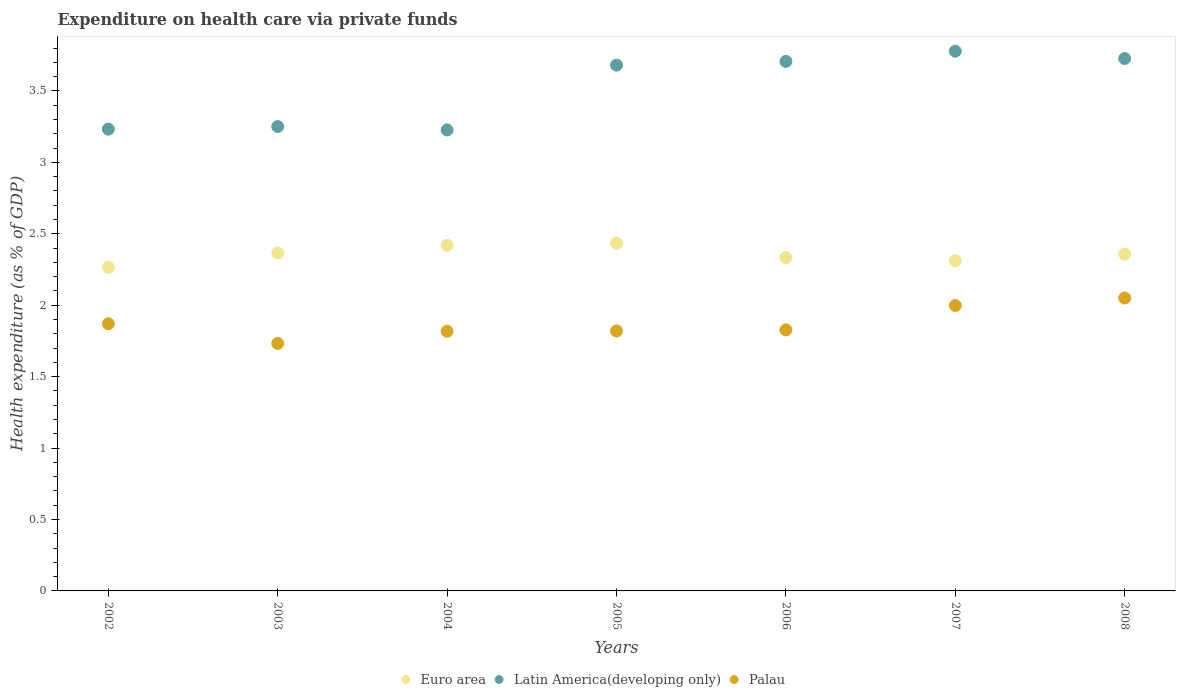Is the number of dotlines equal to the number of legend labels?
Ensure brevity in your answer.  Yes. What is the expenditure made on health care in Palau in 2003?
Ensure brevity in your answer.  1.73. Across all years, what is the maximum expenditure made on health care in Latin America(developing only)?
Your response must be concise. 3.78. Across all years, what is the minimum expenditure made on health care in Euro area?
Your response must be concise. 2.27. What is the total expenditure made on health care in Palau in the graph?
Offer a very short reply. 13.11. What is the difference between the expenditure made on health care in Palau in 2005 and that in 2008?
Keep it short and to the point. -0.23. What is the difference between the expenditure made on health care in Latin America(developing only) in 2006 and the expenditure made on health care in Euro area in 2003?
Your answer should be compact. 1.34. What is the average expenditure made on health care in Latin America(developing only) per year?
Your answer should be compact. 3.51. In the year 2007, what is the difference between the expenditure made on health care in Latin America(developing only) and expenditure made on health care in Palau?
Your answer should be very brief. 1.78. What is the ratio of the expenditure made on health care in Latin America(developing only) in 2004 to that in 2007?
Offer a very short reply. 0.85. Is the difference between the expenditure made on health care in Latin America(developing only) in 2005 and 2008 greater than the difference between the expenditure made on health care in Palau in 2005 and 2008?
Give a very brief answer. Yes. What is the difference between the highest and the second highest expenditure made on health care in Latin America(developing only)?
Provide a succinct answer. 0.05. What is the difference between the highest and the lowest expenditure made on health care in Euro area?
Give a very brief answer. 0.17. In how many years, is the expenditure made on health care in Euro area greater than the average expenditure made on health care in Euro area taken over all years?
Ensure brevity in your answer.  4. Is it the case that in every year, the sum of the expenditure made on health care in Palau and expenditure made on health care in Euro area  is greater than the expenditure made on health care in Latin America(developing only)?
Offer a very short reply. Yes. Does the expenditure made on health care in Palau monotonically increase over the years?
Give a very brief answer. No. Is the expenditure made on health care in Euro area strictly less than the expenditure made on health care in Latin America(developing only) over the years?
Offer a very short reply. Yes. What is the difference between two consecutive major ticks on the Y-axis?
Your answer should be compact. 0.5. Does the graph contain any zero values?
Keep it short and to the point. No. Where does the legend appear in the graph?
Provide a succinct answer. Bottom center. How are the legend labels stacked?
Make the answer very short. Horizontal. What is the title of the graph?
Provide a succinct answer. Expenditure on health care via private funds. What is the label or title of the Y-axis?
Make the answer very short. Health expenditure (as % of GDP). What is the Health expenditure (as % of GDP) of Euro area in 2002?
Keep it short and to the point. 2.27. What is the Health expenditure (as % of GDP) in Latin America(developing only) in 2002?
Offer a terse response. 3.23. What is the Health expenditure (as % of GDP) of Palau in 2002?
Make the answer very short. 1.87. What is the Health expenditure (as % of GDP) in Euro area in 2003?
Your answer should be very brief. 2.36. What is the Health expenditure (as % of GDP) in Latin America(developing only) in 2003?
Ensure brevity in your answer.  3.25. What is the Health expenditure (as % of GDP) in Palau in 2003?
Make the answer very short. 1.73. What is the Health expenditure (as % of GDP) in Euro area in 2004?
Provide a succinct answer. 2.42. What is the Health expenditure (as % of GDP) of Latin America(developing only) in 2004?
Offer a terse response. 3.23. What is the Health expenditure (as % of GDP) of Palau in 2004?
Make the answer very short. 1.82. What is the Health expenditure (as % of GDP) in Euro area in 2005?
Make the answer very short. 2.43. What is the Health expenditure (as % of GDP) of Latin America(developing only) in 2005?
Ensure brevity in your answer.  3.68. What is the Health expenditure (as % of GDP) in Palau in 2005?
Ensure brevity in your answer.  1.82. What is the Health expenditure (as % of GDP) of Euro area in 2006?
Give a very brief answer. 2.33. What is the Health expenditure (as % of GDP) in Latin America(developing only) in 2006?
Your answer should be compact. 3.71. What is the Health expenditure (as % of GDP) of Palau in 2006?
Your response must be concise. 1.83. What is the Health expenditure (as % of GDP) in Euro area in 2007?
Offer a very short reply. 2.31. What is the Health expenditure (as % of GDP) of Latin America(developing only) in 2007?
Offer a terse response. 3.78. What is the Health expenditure (as % of GDP) in Palau in 2007?
Provide a short and direct response. 2. What is the Health expenditure (as % of GDP) of Euro area in 2008?
Make the answer very short. 2.36. What is the Health expenditure (as % of GDP) of Latin America(developing only) in 2008?
Provide a short and direct response. 3.73. What is the Health expenditure (as % of GDP) in Palau in 2008?
Your answer should be compact. 2.05. Across all years, what is the maximum Health expenditure (as % of GDP) in Euro area?
Offer a terse response. 2.43. Across all years, what is the maximum Health expenditure (as % of GDP) in Latin America(developing only)?
Give a very brief answer. 3.78. Across all years, what is the maximum Health expenditure (as % of GDP) of Palau?
Keep it short and to the point. 2.05. Across all years, what is the minimum Health expenditure (as % of GDP) of Euro area?
Provide a short and direct response. 2.27. Across all years, what is the minimum Health expenditure (as % of GDP) of Latin America(developing only)?
Your answer should be very brief. 3.23. Across all years, what is the minimum Health expenditure (as % of GDP) in Palau?
Offer a very short reply. 1.73. What is the total Health expenditure (as % of GDP) in Euro area in the graph?
Provide a succinct answer. 16.49. What is the total Health expenditure (as % of GDP) of Latin America(developing only) in the graph?
Your answer should be compact. 24.6. What is the total Health expenditure (as % of GDP) in Palau in the graph?
Provide a short and direct response. 13.11. What is the difference between the Health expenditure (as % of GDP) in Latin America(developing only) in 2002 and that in 2003?
Your response must be concise. -0.02. What is the difference between the Health expenditure (as % of GDP) in Palau in 2002 and that in 2003?
Keep it short and to the point. 0.14. What is the difference between the Health expenditure (as % of GDP) in Euro area in 2002 and that in 2004?
Keep it short and to the point. -0.15. What is the difference between the Health expenditure (as % of GDP) in Latin America(developing only) in 2002 and that in 2004?
Your answer should be very brief. 0.01. What is the difference between the Health expenditure (as % of GDP) in Palau in 2002 and that in 2004?
Your response must be concise. 0.05. What is the difference between the Health expenditure (as % of GDP) in Euro area in 2002 and that in 2005?
Offer a terse response. -0.17. What is the difference between the Health expenditure (as % of GDP) of Latin America(developing only) in 2002 and that in 2005?
Your answer should be very brief. -0.45. What is the difference between the Health expenditure (as % of GDP) of Palau in 2002 and that in 2005?
Offer a terse response. 0.05. What is the difference between the Health expenditure (as % of GDP) of Euro area in 2002 and that in 2006?
Offer a very short reply. -0.07. What is the difference between the Health expenditure (as % of GDP) of Latin America(developing only) in 2002 and that in 2006?
Your answer should be compact. -0.47. What is the difference between the Health expenditure (as % of GDP) in Palau in 2002 and that in 2006?
Provide a succinct answer. 0.04. What is the difference between the Health expenditure (as % of GDP) of Euro area in 2002 and that in 2007?
Offer a very short reply. -0.05. What is the difference between the Health expenditure (as % of GDP) of Latin America(developing only) in 2002 and that in 2007?
Your answer should be very brief. -0.55. What is the difference between the Health expenditure (as % of GDP) in Palau in 2002 and that in 2007?
Ensure brevity in your answer.  -0.13. What is the difference between the Health expenditure (as % of GDP) of Euro area in 2002 and that in 2008?
Provide a succinct answer. -0.09. What is the difference between the Health expenditure (as % of GDP) in Latin America(developing only) in 2002 and that in 2008?
Ensure brevity in your answer.  -0.49. What is the difference between the Health expenditure (as % of GDP) in Palau in 2002 and that in 2008?
Keep it short and to the point. -0.18. What is the difference between the Health expenditure (as % of GDP) of Euro area in 2003 and that in 2004?
Give a very brief answer. -0.05. What is the difference between the Health expenditure (as % of GDP) of Latin America(developing only) in 2003 and that in 2004?
Provide a short and direct response. 0.02. What is the difference between the Health expenditure (as % of GDP) in Palau in 2003 and that in 2004?
Ensure brevity in your answer.  -0.09. What is the difference between the Health expenditure (as % of GDP) in Euro area in 2003 and that in 2005?
Your answer should be compact. -0.07. What is the difference between the Health expenditure (as % of GDP) of Latin America(developing only) in 2003 and that in 2005?
Make the answer very short. -0.43. What is the difference between the Health expenditure (as % of GDP) of Palau in 2003 and that in 2005?
Keep it short and to the point. -0.09. What is the difference between the Health expenditure (as % of GDP) of Euro area in 2003 and that in 2006?
Keep it short and to the point. 0.03. What is the difference between the Health expenditure (as % of GDP) of Latin America(developing only) in 2003 and that in 2006?
Ensure brevity in your answer.  -0.46. What is the difference between the Health expenditure (as % of GDP) of Palau in 2003 and that in 2006?
Offer a terse response. -0.09. What is the difference between the Health expenditure (as % of GDP) in Euro area in 2003 and that in 2007?
Offer a very short reply. 0.05. What is the difference between the Health expenditure (as % of GDP) in Latin America(developing only) in 2003 and that in 2007?
Offer a very short reply. -0.53. What is the difference between the Health expenditure (as % of GDP) of Palau in 2003 and that in 2007?
Your answer should be compact. -0.27. What is the difference between the Health expenditure (as % of GDP) in Euro area in 2003 and that in 2008?
Your response must be concise. 0.01. What is the difference between the Health expenditure (as % of GDP) in Latin America(developing only) in 2003 and that in 2008?
Keep it short and to the point. -0.48. What is the difference between the Health expenditure (as % of GDP) of Palau in 2003 and that in 2008?
Offer a terse response. -0.32. What is the difference between the Health expenditure (as % of GDP) of Euro area in 2004 and that in 2005?
Offer a very short reply. -0.01. What is the difference between the Health expenditure (as % of GDP) of Latin America(developing only) in 2004 and that in 2005?
Offer a terse response. -0.45. What is the difference between the Health expenditure (as % of GDP) in Palau in 2004 and that in 2005?
Offer a very short reply. -0. What is the difference between the Health expenditure (as % of GDP) in Euro area in 2004 and that in 2006?
Your answer should be compact. 0.09. What is the difference between the Health expenditure (as % of GDP) in Latin America(developing only) in 2004 and that in 2006?
Provide a short and direct response. -0.48. What is the difference between the Health expenditure (as % of GDP) in Palau in 2004 and that in 2006?
Ensure brevity in your answer.  -0.01. What is the difference between the Health expenditure (as % of GDP) of Euro area in 2004 and that in 2007?
Give a very brief answer. 0.11. What is the difference between the Health expenditure (as % of GDP) in Latin America(developing only) in 2004 and that in 2007?
Keep it short and to the point. -0.55. What is the difference between the Health expenditure (as % of GDP) in Palau in 2004 and that in 2007?
Give a very brief answer. -0.18. What is the difference between the Health expenditure (as % of GDP) of Euro area in 2004 and that in 2008?
Your answer should be very brief. 0.06. What is the difference between the Health expenditure (as % of GDP) of Latin America(developing only) in 2004 and that in 2008?
Offer a very short reply. -0.5. What is the difference between the Health expenditure (as % of GDP) in Palau in 2004 and that in 2008?
Keep it short and to the point. -0.23. What is the difference between the Health expenditure (as % of GDP) in Euro area in 2005 and that in 2006?
Your answer should be compact. 0.1. What is the difference between the Health expenditure (as % of GDP) of Latin America(developing only) in 2005 and that in 2006?
Your response must be concise. -0.03. What is the difference between the Health expenditure (as % of GDP) of Palau in 2005 and that in 2006?
Offer a terse response. -0.01. What is the difference between the Health expenditure (as % of GDP) of Euro area in 2005 and that in 2007?
Give a very brief answer. 0.12. What is the difference between the Health expenditure (as % of GDP) in Latin America(developing only) in 2005 and that in 2007?
Offer a terse response. -0.1. What is the difference between the Health expenditure (as % of GDP) of Palau in 2005 and that in 2007?
Ensure brevity in your answer.  -0.18. What is the difference between the Health expenditure (as % of GDP) of Euro area in 2005 and that in 2008?
Your answer should be compact. 0.08. What is the difference between the Health expenditure (as % of GDP) of Latin America(developing only) in 2005 and that in 2008?
Offer a terse response. -0.05. What is the difference between the Health expenditure (as % of GDP) of Palau in 2005 and that in 2008?
Your answer should be compact. -0.23. What is the difference between the Health expenditure (as % of GDP) in Euro area in 2006 and that in 2007?
Keep it short and to the point. 0.02. What is the difference between the Health expenditure (as % of GDP) in Latin America(developing only) in 2006 and that in 2007?
Offer a very short reply. -0.07. What is the difference between the Health expenditure (as % of GDP) of Palau in 2006 and that in 2007?
Your answer should be compact. -0.17. What is the difference between the Health expenditure (as % of GDP) in Euro area in 2006 and that in 2008?
Provide a short and direct response. -0.03. What is the difference between the Health expenditure (as % of GDP) of Latin America(developing only) in 2006 and that in 2008?
Your answer should be compact. -0.02. What is the difference between the Health expenditure (as % of GDP) of Palau in 2006 and that in 2008?
Your answer should be compact. -0.22. What is the difference between the Health expenditure (as % of GDP) in Euro area in 2007 and that in 2008?
Offer a very short reply. -0.05. What is the difference between the Health expenditure (as % of GDP) in Latin America(developing only) in 2007 and that in 2008?
Provide a succinct answer. 0.05. What is the difference between the Health expenditure (as % of GDP) of Palau in 2007 and that in 2008?
Provide a short and direct response. -0.05. What is the difference between the Health expenditure (as % of GDP) of Euro area in 2002 and the Health expenditure (as % of GDP) of Latin America(developing only) in 2003?
Your response must be concise. -0.99. What is the difference between the Health expenditure (as % of GDP) in Euro area in 2002 and the Health expenditure (as % of GDP) in Palau in 2003?
Make the answer very short. 0.53. What is the difference between the Health expenditure (as % of GDP) of Euro area in 2002 and the Health expenditure (as % of GDP) of Latin America(developing only) in 2004?
Provide a succinct answer. -0.96. What is the difference between the Health expenditure (as % of GDP) in Euro area in 2002 and the Health expenditure (as % of GDP) in Palau in 2004?
Provide a short and direct response. 0.45. What is the difference between the Health expenditure (as % of GDP) in Latin America(developing only) in 2002 and the Health expenditure (as % of GDP) in Palau in 2004?
Your answer should be compact. 1.41. What is the difference between the Health expenditure (as % of GDP) in Euro area in 2002 and the Health expenditure (as % of GDP) in Latin America(developing only) in 2005?
Offer a very short reply. -1.42. What is the difference between the Health expenditure (as % of GDP) in Euro area in 2002 and the Health expenditure (as % of GDP) in Palau in 2005?
Your response must be concise. 0.45. What is the difference between the Health expenditure (as % of GDP) in Latin America(developing only) in 2002 and the Health expenditure (as % of GDP) in Palau in 2005?
Your response must be concise. 1.41. What is the difference between the Health expenditure (as % of GDP) of Euro area in 2002 and the Health expenditure (as % of GDP) of Latin America(developing only) in 2006?
Give a very brief answer. -1.44. What is the difference between the Health expenditure (as % of GDP) of Euro area in 2002 and the Health expenditure (as % of GDP) of Palau in 2006?
Provide a succinct answer. 0.44. What is the difference between the Health expenditure (as % of GDP) in Latin America(developing only) in 2002 and the Health expenditure (as % of GDP) in Palau in 2006?
Keep it short and to the point. 1.41. What is the difference between the Health expenditure (as % of GDP) of Euro area in 2002 and the Health expenditure (as % of GDP) of Latin America(developing only) in 2007?
Keep it short and to the point. -1.51. What is the difference between the Health expenditure (as % of GDP) of Euro area in 2002 and the Health expenditure (as % of GDP) of Palau in 2007?
Make the answer very short. 0.27. What is the difference between the Health expenditure (as % of GDP) in Latin America(developing only) in 2002 and the Health expenditure (as % of GDP) in Palau in 2007?
Your answer should be very brief. 1.23. What is the difference between the Health expenditure (as % of GDP) of Euro area in 2002 and the Health expenditure (as % of GDP) of Latin America(developing only) in 2008?
Provide a succinct answer. -1.46. What is the difference between the Health expenditure (as % of GDP) of Euro area in 2002 and the Health expenditure (as % of GDP) of Palau in 2008?
Give a very brief answer. 0.22. What is the difference between the Health expenditure (as % of GDP) in Latin America(developing only) in 2002 and the Health expenditure (as % of GDP) in Palau in 2008?
Provide a succinct answer. 1.18. What is the difference between the Health expenditure (as % of GDP) of Euro area in 2003 and the Health expenditure (as % of GDP) of Latin America(developing only) in 2004?
Your response must be concise. -0.86. What is the difference between the Health expenditure (as % of GDP) of Euro area in 2003 and the Health expenditure (as % of GDP) of Palau in 2004?
Your response must be concise. 0.55. What is the difference between the Health expenditure (as % of GDP) of Latin America(developing only) in 2003 and the Health expenditure (as % of GDP) of Palau in 2004?
Provide a succinct answer. 1.43. What is the difference between the Health expenditure (as % of GDP) in Euro area in 2003 and the Health expenditure (as % of GDP) in Latin America(developing only) in 2005?
Offer a terse response. -1.32. What is the difference between the Health expenditure (as % of GDP) of Euro area in 2003 and the Health expenditure (as % of GDP) of Palau in 2005?
Provide a short and direct response. 0.55. What is the difference between the Health expenditure (as % of GDP) of Latin America(developing only) in 2003 and the Health expenditure (as % of GDP) of Palau in 2005?
Provide a short and direct response. 1.43. What is the difference between the Health expenditure (as % of GDP) of Euro area in 2003 and the Health expenditure (as % of GDP) of Latin America(developing only) in 2006?
Your answer should be compact. -1.34. What is the difference between the Health expenditure (as % of GDP) in Euro area in 2003 and the Health expenditure (as % of GDP) in Palau in 2006?
Your answer should be very brief. 0.54. What is the difference between the Health expenditure (as % of GDP) of Latin America(developing only) in 2003 and the Health expenditure (as % of GDP) of Palau in 2006?
Provide a short and direct response. 1.42. What is the difference between the Health expenditure (as % of GDP) of Euro area in 2003 and the Health expenditure (as % of GDP) of Latin America(developing only) in 2007?
Offer a very short reply. -1.41. What is the difference between the Health expenditure (as % of GDP) of Euro area in 2003 and the Health expenditure (as % of GDP) of Palau in 2007?
Your response must be concise. 0.37. What is the difference between the Health expenditure (as % of GDP) of Latin America(developing only) in 2003 and the Health expenditure (as % of GDP) of Palau in 2007?
Give a very brief answer. 1.25. What is the difference between the Health expenditure (as % of GDP) in Euro area in 2003 and the Health expenditure (as % of GDP) in Latin America(developing only) in 2008?
Make the answer very short. -1.36. What is the difference between the Health expenditure (as % of GDP) in Euro area in 2003 and the Health expenditure (as % of GDP) in Palau in 2008?
Offer a terse response. 0.32. What is the difference between the Health expenditure (as % of GDP) of Latin America(developing only) in 2003 and the Health expenditure (as % of GDP) of Palau in 2008?
Provide a succinct answer. 1.2. What is the difference between the Health expenditure (as % of GDP) in Euro area in 2004 and the Health expenditure (as % of GDP) in Latin America(developing only) in 2005?
Offer a very short reply. -1.26. What is the difference between the Health expenditure (as % of GDP) of Euro area in 2004 and the Health expenditure (as % of GDP) of Palau in 2005?
Give a very brief answer. 0.6. What is the difference between the Health expenditure (as % of GDP) in Latin America(developing only) in 2004 and the Health expenditure (as % of GDP) in Palau in 2005?
Your answer should be very brief. 1.41. What is the difference between the Health expenditure (as % of GDP) in Euro area in 2004 and the Health expenditure (as % of GDP) in Latin America(developing only) in 2006?
Provide a succinct answer. -1.29. What is the difference between the Health expenditure (as % of GDP) in Euro area in 2004 and the Health expenditure (as % of GDP) in Palau in 2006?
Offer a terse response. 0.59. What is the difference between the Health expenditure (as % of GDP) in Latin America(developing only) in 2004 and the Health expenditure (as % of GDP) in Palau in 2006?
Provide a short and direct response. 1.4. What is the difference between the Health expenditure (as % of GDP) in Euro area in 2004 and the Health expenditure (as % of GDP) in Latin America(developing only) in 2007?
Ensure brevity in your answer.  -1.36. What is the difference between the Health expenditure (as % of GDP) of Euro area in 2004 and the Health expenditure (as % of GDP) of Palau in 2007?
Ensure brevity in your answer.  0.42. What is the difference between the Health expenditure (as % of GDP) in Latin America(developing only) in 2004 and the Health expenditure (as % of GDP) in Palau in 2007?
Give a very brief answer. 1.23. What is the difference between the Health expenditure (as % of GDP) of Euro area in 2004 and the Health expenditure (as % of GDP) of Latin America(developing only) in 2008?
Keep it short and to the point. -1.31. What is the difference between the Health expenditure (as % of GDP) in Euro area in 2004 and the Health expenditure (as % of GDP) in Palau in 2008?
Your answer should be very brief. 0.37. What is the difference between the Health expenditure (as % of GDP) in Latin America(developing only) in 2004 and the Health expenditure (as % of GDP) in Palau in 2008?
Provide a short and direct response. 1.18. What is the difference between the Health expenditure (as % of GDP) in Euro area in 2005 and the Health expenditure (as % of GDP) in Latin America(developing only) in 2006?
Offer a terse response. -1.27. What is the difference between the Health expenditure (as % of GDP) of Euro area in 2005 and the Health expenditure (as % of GDP) of Palau in 2006?
Give a very brief answer. 0.61. What is the difference between the Health expenditure (as % of GDP) of Latin America(developing only) in 2005 and the Health expenditure (as % of GDP) of Palau in 2006?
Provide a short and direct response. 1.85. What is the difference between the Health expenditure (as % of GDP) of Euro area in 2005 and the Health expenditure (as % of GDP) of Latin America(developing only) in 2007?
Provide a short and direct response. -1.34. What is the difference between the Health expenditure (as % of GDP) in Euro area in 2005 and the Health expenditure (as % of GDP) in Palau in 2007?
Your response must be concise. 0.44. What is the difference between the Health expenditure (as % of GDP) of Latin America(developing only) in 2005 and the Health expenditure (as % of GDP) of Palau in 2007?
Offer a terse response. 1.68. What is the difference between the Health expenditure (as % of GDP) in Euro area in 2005 and the Health expenditure (as % of GDP) in Latin America(developing only) in 2008?
Give a very brief answer. -1.29. What is the difference between the Health expenditure (as % of GDP) in Euro area in 2005 and the Health expenditure (as % of GDP) in Palau in 2008?
Your response must be concise. 0.38. What is the difference between the Health expenditure (as % of GDP) of Latin America(developing only) in 2005 and the Health expenditure (as % of GDP) of Palau in 2008?
Your answer should be very brief. 1.63. What is the difference between the Health expenditure (as % of GDP) in Euro area in 2006 and the Health expenditure (as % of GDP) in Latin America(developing only) in 2007?
Provide a short and direct response. -1.45. What is the difference between the Health expenditure (as % of GDP) of Euro area in 2006 and the Health expenditure (as % of GDP) of Palau in 2007?
Your answer should be very brief. 0.34. What is the difference between the Health expenditure (as % of GDP) of Latin America(developing only) in 2006 and the Health expenditure (as % of GDP) of Palau in 2007?
Provide a short and direct response. 1.71. What is the difference between the Health expenditure (as % of GDP) of Euro area in 2006 and the Health expenditure (as % of GDP) of Latin America(developing only) in 2008?
Provide a short and direct response. -1.39. What is the difference between the Health expenditure (as % of GDP) in Euro area in 2006 and the Health expenditure (as % of GDP) in Palau in 2008?
Offer a terse response. 0.28. What is the difference between the Health expenditure (as % of GDP) of Latin America(developing only) in 2006 and the Health expenditure (as % of GDP) of Palau in 2008?
Offer a terse response. 1.66. What is the difference between the Health expenditure (as % of GDP) of Euro area in 2007 and the Health expenditure (as % of GDP) of Latin America(developing only) in 2008?
Provide a short and direct response. -1.41. What is the difference between the Health expenditure (as % of GDP) of Euro area in 2007 and the Health expenditure (as % of GDP) of Palau in 2008?
Ensure brevity in your answer.  0.26. What is the difference between the Health expenditure (as % of GDP) in Latin America(developing only) in 2007 and the Health expenditure (as % of GDP) in Palau in 2008?
Keep it short and to the point. 1.73. What is the average Health expenditure (as % of GDP) of Euro area per year?
Your answer should be very brief. 2.36. What is the average Health expenditure (as % of GDP) in Latin America(developing only) per year?
Keep it short and to the point. 3.51. What is the average Health expenditure (as % of GDP) in Palau per year?
Give a very brief answer. 1.87. In the year 2002, what is the difference between the Health expenditure (as % of GDP) in Euro area and Health expenditure (as % of GDP) in Latin America(developing only)?
Make the answer very short. -0.97. In the year 2002, what is the difference between the Health expenditure (as % of GDP) of Euro area and Health expenditure (as % of GDP) of Palau?
Offer a very short reply. 0.39. In the year 2002, what is the difference between the Health expenditure (as % of GDP) in Latin America(developing only) and Health expenditure (as % of GDP) in Palau?
Your answer should be very brief. 1.36. In the year 2003, what is the difference between the Health expenditure (as % of GDP) of Euro area and Health expenditure (as % of GDP) of Latin America(developing only)?
Provide a short and direct response. -0.89. In the year 2003, what is the difference between the Health expenditure (as % of GDP) of Euro area and Health expenditure (as % of GDP) of Palau?
Make the answer very short. 0.63. In the year 2003, what is the difference between the Health expenditure (as % of GDP) in Latin America(developing only) and Health expenditure (as % of GDP) in Palau?
Provide a succinct answer. 1.52. In the year 2004, what is the difference between the Health expenditure (as % of GDP) of Euro area and Health expenditure (as % of GDP) of Latin America(developing only)?
Offer a very short reply. -0.81. In the year 2004, what is the difference between the Health expenditure (as % of GDP) of Euro area and Health expenditure (as % of GDP) of Palau?
Provide a succinct answer. 0.6. In the year 2004, what is the difference between the Health expenditure (as % of GDP) in Latin America(developing only) and Health expenditure (as % of GDP) in Palau?
Provide a short and direct response. 1.41. In the year 2005, what is the difference between the Health expenditure (as % of GDP) in Euro area and Health expenditure (as % of GDP) in Latin America(developing only)?
Your answer should be very brief. -1.25. In the year 2005, what is the difference between the Health expenditure (as % of GDP) in Euro area and Health expenditure (as % of GDP) in Palau?
Ensure brevity in your answer.  0.61. In the year 2005, what is the difference between the Health expenditure (as % of GDP) in Latin America(developing only) and Health expenditure (as % of GDP) in Palau?
Your answer should be very brief. 1.86. In the year 2006, what is the difference between the Health expenditure (as % of GDP) of Euro area and Health expenditure (as % of GDP) of Latin America(developing only)?
Make the answer very short. -1.37. In the year 2006, what is the difference between the Health expenditure (as % of GDP) in Euro area and Health expenditure (as % of GDP) in Palau?
Offer a terse response. 0.51. In the year 2006, what is the difference between the Health expenditure (as % of GDP) in Latin America(developing only) and Health expenditure (as % of GDP) in Palau?
Your answer should be very brief. 1.88. In the year 2007, what is the difference between the Health expenditure (as % of GDP) in Euro area and Health expenditure (as % of GDP) in Latin America(developing only)?
Offer a very short reply. -1.47. In the year 2007, what is the difference between the Health expenditure (as % of GDP) in Euro area and Health expenditure (as % of GDP) in Palau?
Your response must be concise. 0.31. In the year 2007, what is the difference between the Health expenditure (as % of GDP) of Latin America(developing only) and Health expenditure (as % of GDP) of Palau?
Offer a very short reply. 1.78. In the year 2008, what is the difference between the Health expenditure (as % of GDP) in Euro area and Health expenditure (as % of GDP) in Latin America(developing only)?
Your answer should be very brief. -1.37. In the year 2008, what is the difference between the Health expenditure (as % of GDP) of Euro area and Health expenditure (as % of GDP) of Palau?
Your answer should be very brief. 0.31. In the year 2008, what is the difference between the Health expenditure (as % of GDP) in Latin America(developing only) and Health expenditure (as % of GDP) in Palau?
Your answer should be very brief. 1.68. What is the ratio of the Health expenditure (as % of GDP) of Euro area in 2002 to that in 2003?
Make the answer very short. 0.96. What is the ratio of the Health expenditure (as % of GDP) in Latin America(developing only) in 2002 to that in 2003?
Give a very brief answer. 0.99. What is the ratio of the Health expenditure (as % of GDP) of Palau in 2002 to that in 2003?
Keep it short and to the point. 1.08. What is the ratio of the Health expenditure (as % of GDP) in Euro area in 2002 to that in 2004?
Your response must be concise. 0.94. What is the ratio of the Health expenditure (as % of GDP) in Euro area in 2002 to that in 2005?
Your response must be concise. 0.93. What is the ratio of the Health expenditure (as % of GDP) of Latin America(developing only) in 2002 to that in 2005?
Offer a very short reply. 0.88. What is the ratio of the Health expenditure (as % of GDP) in Palau in 2002 to that in 2005?
Give a very brief answer. 1.03. What is the ratio of the Health expenditure (as % of GDP) in Euro area in 2002 to that in 2006?
Your answer should be very brief. 0.97. What is the ratio of the Health expenditure (as % of GDP) of Latin America(developing only) in 2002 to that in 2006?
Offer a terse response. 0.87. What is the ratio of the Health expenditure (as % of GDP) in Palau in 2002 to that in 2006?
Your answer should be very brief. 1.02. What is the ratio of the Health expenditure (as % of GDP) of Euro area in 2002 to that in 2007?
Offer a very short reply. 0.98. What is the ratio of the Health expenditure (as % of GDP) in Latin America(developing only) in 2002 to that in 2007?
Your answer should be very brief. 0.86. What is the ratio of the Health expenditure (as % of GDP) in Palau in 2002 to that in 2007?
Your answer should be compact. 0.94. What is the ratio of the Health expenditure (as % of GDP) of Euro area in 2002 to that in 2008?
Provide a succinct answer. 0.96. What is the ratio of the Health expenditure (as % of GDP) of Latin America(developing only) in 2002 to that in 2008?
Keep it short and to the point. 0.87. What is the ratio of the Health expenditure (as % of GDP) in Palau in 2002 to that in 2008?
Your answer should be compact. 0.91. What is the ratio of the Health expenditure (as % of GDP) in Euro area in 2003 to that in 2004?
Offer a very short reply. 0.98. What is the ratio of the Health expenditure (as % of GDP) in Latin America(developing only) in 2003 to that in 2004?
Give a very brief answer. 1.01. What is the ratio of the Health expenditure (as % of GDP) in Palau in 2003 to that in 2004?
Ensure brevity in your answer.  0.95. What is the ratio of the Health expenditure (as % of GDP) in Euro area in 2003 to that in 2005?
Make the answer very short. 0.97. What is the ratio of the Health expenditure (as % of GDP) in Latin America(developing only) in 2003 to that in 2005?
Give a very brief answer. 0.88. What is the ratio of the Health expenditure (as % of GDP) in Euro area in 2003 to that in 2006?
Your answer should be very brief. 1.01. What is the ratio of the Health expenditure (as % of GDP) in Latin America(developing only) in 2003 to that in 2006?
Provide a succinct answer. 0.88. What is the ratio of the Health expenditure (as % of GDP) in Palau in 2003 to that in 2006?
Provide a short and direct response. 0.95. What is the ratio of the Health expenditure (as % of GDP) in Latin America(developing only) in 2003 to that in 2007?
Give a very brief answer. 0.86. What is the ratio of the Health expenditure (as % of GDP) of Palau in 2003 to that in 2007?
Make the answer very short. 0.87. What is the ratio of the Health expenditure (as % of GDP) in Latin America(developing only) in 2003 to that in 2008?
Provide a short and direct response. 0.87. What is the ratio of the Health expenditure (as % of GDP) in Palau in 2003 to that in 2008?
Give a very brief answer. 0.84. What is the ratio of the Health expenditure (as % of GDP) of Euro area in 2004 to that in 2005?
Provide a short and direct response. 0.99. What is the ratio of the Health expenditure (as % of GDP) in Latin America(developing only) in 2004 to that in 2005?
Offer a very short reply. 0.88. What is the ratio of the Health expenditure (as % of GDP) of Euro area in 2004 to that in 2006?
Keep it short and to the point. 1.04. What is the ratio of the Health expenditure (as % of GDP) of Latin America(developing only) in 2004 to that in 2006?
Your answer should be very brief. 0.87. What is the ratio of the Health expenditure (as % of GDP) in Euro area in 2004 to that in 2007?
Ensure brevity in your answer.  1.05. What is the ratio of the Health expenditure (as % of GDP) of Latin America(developing only) in 2004 to that in 2007?
Offer a terse response. 0.85. What is the ratio of the Health expenditure (as % of GDP) of Palau in 2004 to that in 2007?
Make the answer very short. 0.91. What is the ratio of the Health expenditure (as % of GDP) of Euro area in 2004 to that in 2008?
Your answer should be compact. 1.03. What is the ratio of the Health expenditure (as % of GDP) of Latin America(developing only) in 2004 to that in 2008?
Provide a short and direct response. 0.87. What is the ratio of the Health expenditure (as % of GDP) of Palau in 2004 to that in 2008?
Offer a terse response. 0.89. What is the ratio of the Health expenditure (as % of GDP) in Euro area in 2005 to that in 2006?
Give a very brief answer. 1.04. What is the ratio of the Health expenditure (as % of GDP) of Latin America(developing only) in 2005 to that in 2006?
Ensure brevity in your answer.  0.99. What is the ratio of the Health expenditure (as % of GDP) in Palau in 2005 to that in 2006?
Your response must be concise. 1. What is the ratio of the Health expenditure (as % of GDP) of Euro area in 2005 to that in 2007?
Give a very brief answer. 1.05. What is the ratio of the Health expenditure (as % of GDP) in Latin America(developing only) in 2005 to that in 2007?
Your answer should be very brief. 0.97. What is the ratio of the Health expenditure (as % of GDP) in Palau in 2005 to that in 2007?
Make the answer very short. 0.91. What is the ratio of the Health expenditure (as % of GDP) in Euro area in 2005 to that in 2008?
Provide a short and direct response. 1.03. What is the ratio of the Health expenditure (as % of GDP) in Latin America(developing only) in 2005 to that in 2008?
Provide a short and direct response. 0.99. What is the ratio of the Health expenditure (as % of GDP) in Palau in 2005 to that in 2008?
Your response must be concise. 0.89. What is the ratio of the Health expenditure (as % of GDP) of Euro area in 2006 to that in 2007?
Ensure brevity in your answer.  1.01. What is the ratio of the Health expenditure (as % of GDP) of Latin America(developing only) in 2006 to that in 2007?
Offer a terse response. 0.98. What is the ratio of the Health expenditure (as % of GDP) in Palau in 2006 to that in 2007?
Your response must be concise. 0.91. What is the ratio of the Health expenditure (as % of GDP) in Euro area in 2006 to that in 2008?
Keep it short and to the point. 0.99. What is the ratio of the Health expenditure (as % of GDP) of Latin America(developing only) in 2006 to that in 2008?
Give a very brief answer. 0.99. What is the ratio of the Health expenditure (as % of GDP) in Palau in 2006 to that in 2008?
Offer a very short reply. 0.89. What is the ratio of the Health expenditure (as % of GDP) in Euro area in 2007 to that in 2008?
Provide a succinct answer. 0.98. What is the ratio of the Health expenditure (as % of GDP) in Latin America(developing only) in 2007 to that in 2008?
Your response must be concise. 1.01. What is the ratio of the Health expenditure (as % of GDP) of Palau in 2007 to that in 2008?
Offer a very short reply. 0.97. What is the difference between the highest and the second highest Health expenditure (as % of GDP) in Euro area?
Offer a very short reply. 0.01. What is the difference between the highest and the second highest Health expenditure (as % of GDP) in Latin America(developing only)?
Provide a short and direct response. 0.05. What is the difference between the highest and the second highest Health expenditure (as % of GDP) in Palau?
Make the answer very short. 0.05. What is the difference between the highest and the lowest Health expenditure (as % of GDP) of Euro area?
Keep it short and to the point. 0.17. What is the difference between the highest and the lowest Health expenditure (as % of GDP) in Latin America(developing only)?
Offer a terse response. 0.55. What is the difference between the highest and the lowest Health expenditure (as % of GDP) in Palau?
Make the answer very short. 0.32. 